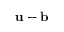<formula> <loc_0><loc_0><loc_500><loc_500>u - b</formula> 